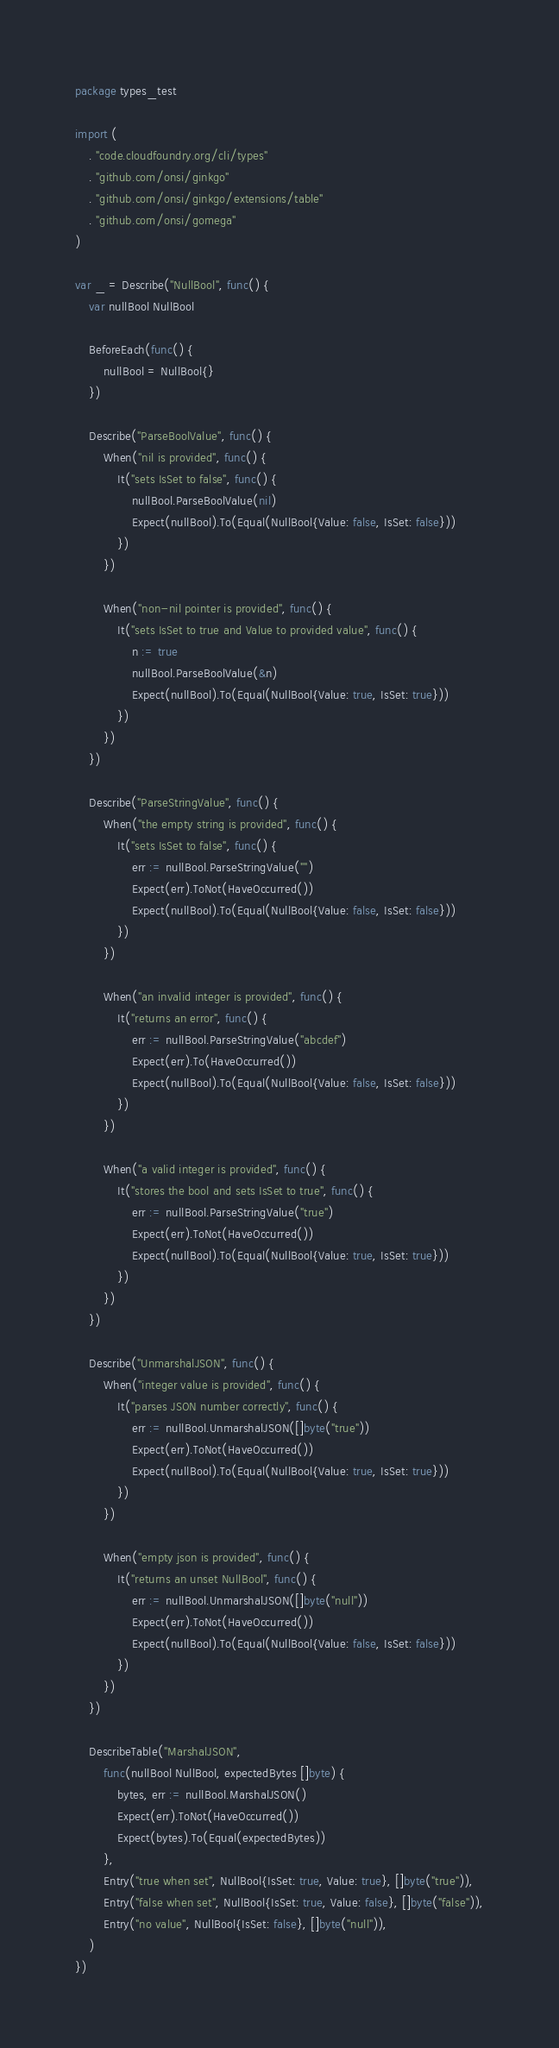<code> <loc_0><loc_0><loc_500><loc_500><_Go_>package types_test

import (
	. "code.cloudfoundry.org/cli/types"
	. "github.com/onsi/ginkgo"
	. "github.com/onsi/ginkgo/extensions/table"
	. "github.com/onsi/gomega"
)

var _ = Describe("NullBool", func() {
	var nullBool NullBool

	BeforeEach(func() {
		nullBool = NullBool{}
	})

	Describe("ParseBoolValue", func() {
		When("nil is provided", func() {
			It("sets IsSet to false", func() {
				nullBool.ParseBoolValue(nil)
				Expect(nullBool).To(Equal(NullBool{Value: false, IsSet: false}))
			})
		})

		When("non-nil pointer is provided", func() {
			It("sets IsSet to true and Value to provided value", func() {
				n := true
				nullBool.ParseBoolValue(&n)
				Expect(nullBool).To(Equal(NullBool{Value: true, IsSet: true}))
			})
		})
	})

	Describe("ParseStringValue", func() {
		When("the empty string is provided", func() {
			It("sets IsSet to false", func() {
				err := nullBool.ParseStringValue("")
				Expect(err).ToNot(HaveOccurred())
				Expect(nullBool).To(Equal(NullBool{Value: false, IsSet: false}))
			})
		})

		When("an invalid integer is provided", func() {
			It("returns an error", func() {
				err := nullBool.ParseStringValue("abcdef")
				Expect(err).To(HaveOccurred())
				Expect(nullBool).To(Equal(NullBool{Value: false, IsSet: false}))
			})
		})

		When("a valid integer is provided", func() {
			It("stores the bool and sets IsSet to true", func() {
				err := nullBool.ParseStringValue("true")
				Expect(err).ToNot(HaveOccurred())
				Expect(nullBool).To(Equal(NullBool{Value: true, IsSet: true}))
			})
		})
	})

	Describe("UnmarshalJSON", func() {
		When("integer value is provided", func() {
			It("parses JSON number correctly", func() {
				err := nullBool.UnmarshalJSON([]byte("true"))
				Expect(err).ToNot(HaveOccurred())
				Expect(nullBool).To(Equal(NullBool{Value: true, IsSet: true}))
			})
		})

		When("empty json is provided", func() {
			It("returns an unset NullBool", func() {
				err := nullBool.UnmarshalJSON([]byte("null"))
				Expect(err).ToNot(HaveOccurred())
				Expect(nullBool).To(Equal(NullBool{Value: false, IsSet: false}))
			})
		})
	})

	DescribeTable("MarshalJSON",
		func(nullBool NullBool, expectedBytes []byte) {
			bytes, err := nullBool.MarshalJSON()
			Expect(err).ToNot(HaveOccurred())
			Expect(bytes).To(Equal(expectedBytes))
		},
		Entry("true when set", NullBool{IsSet: true, Value: true}, []byte("true")),
		Entry("false when set", NullBool{IsSet: true, Value: false}, []byte("false")),
		Entry("no value", NullBool{IsSet: false}, []byte("null")),
	)
})
</code> 